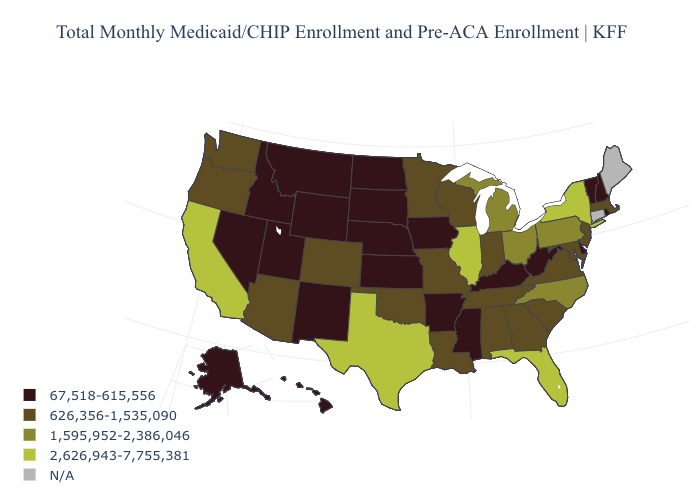Name the states that have a value in the range 626,356-1,535,090?
Quick response, please. Alabama, Arizona, Colorado, Georgia, Indiana, Louisiana, Maryland, Massachusetts, Minnesota, Missouri, New Jersey, Oklahoma, Oregon, South Carolina, Tennessee, Virginia, Washington, Wisconsin. What is the value of Louisiana?
Concise answer only. 626,356-1,535,090. What is the lowest value in the Northeast?
Write a very short answer. 67,518-615,556. Name the states that have a value in the range 626,356-1,535,090?
Concise answer only. Alabama, Arizona, Colorado, Georgia, Indiana, Louisiana, Maryland, Massachusetts, Minnesota, Missouri, New Jersey, Oklahoma, Oregon, South Carolina, Tennessee, Virginia, Washington, Wisconsin. Does Mississippi have the lowest value in the South?
Keep it brief. Yes. What is the value of Delaware?
Answer briefly. 67,518-615,556. How many symbols are there in the legend?
Short answer required. 5. What is the value of Wisconsin?
Give a very brief answer. 626,356-1,535,090. Does the map have missing data?
Answer briefly. Yes. What is the value of Kentucky?
Short answer required. 67,518-615,556. What is the value of South Carolina?
Keep it brief. 626,356-1,535,090. Name the states that have a value in the range N/A?
Concise answer only. Connecticut, Maine. What is the lowest value in states that border Montana?
Be succinct. 67,518-615,556. What is the highest value in the MidWest ?
Be succinct. 2,626,943-7,755,381. 